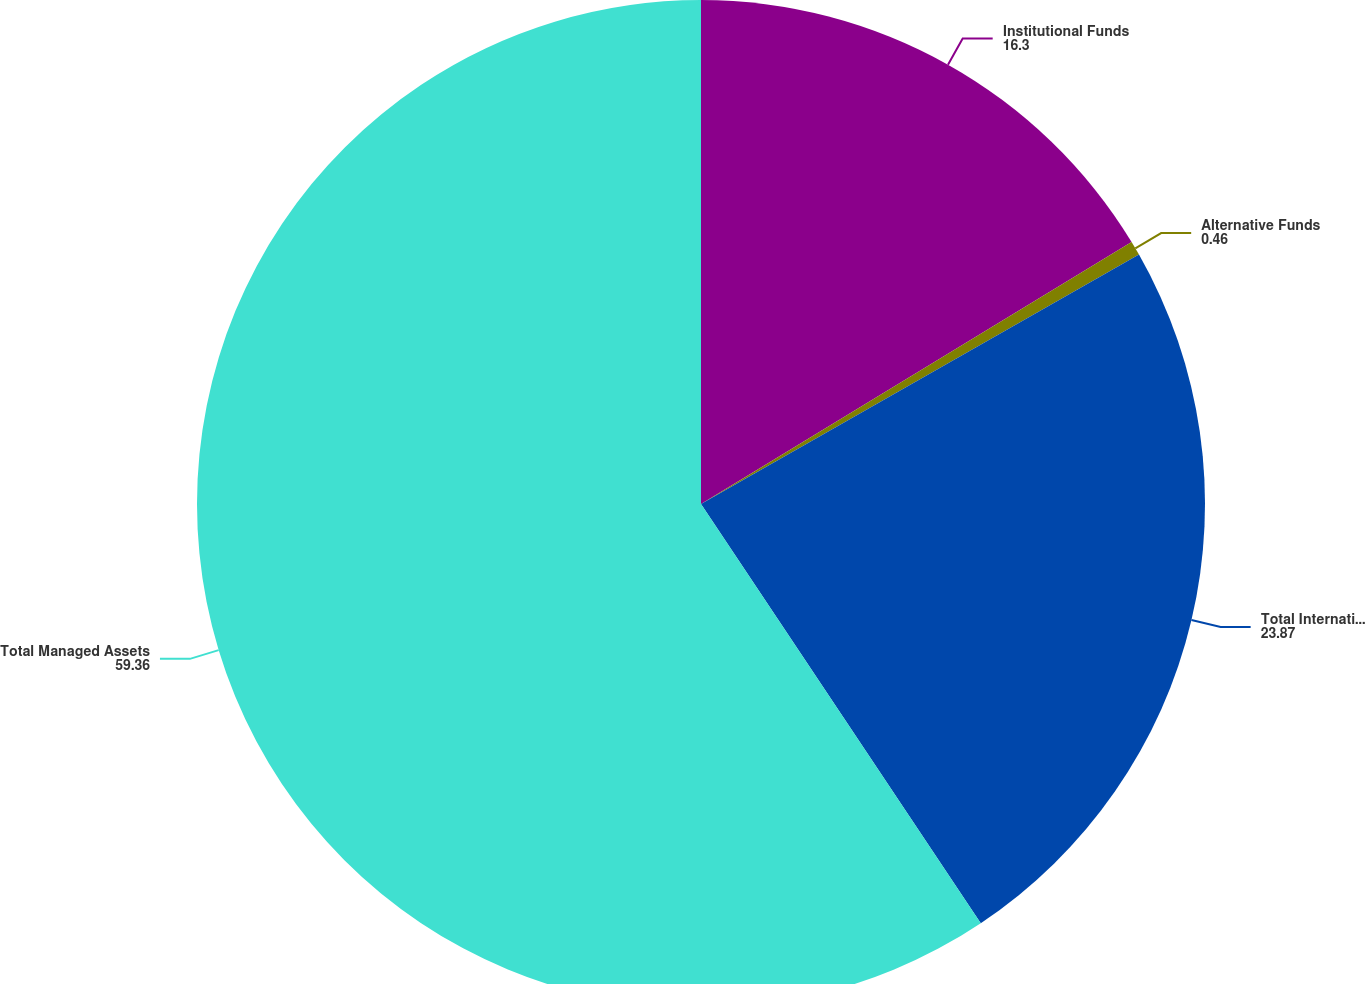Convert chart to OTSL. <chart><loc_0><loc_0><loc_500><loc_500><pie_chart><fcel>Institutional Funds<fcel>Alternative Funds<fcel>Total International Managed<fcel>Total Managed Assets<nl><fcel>16.3%<fcel>0.46%<fcel>23.87%<fcel>59.36%<nl></chart> 